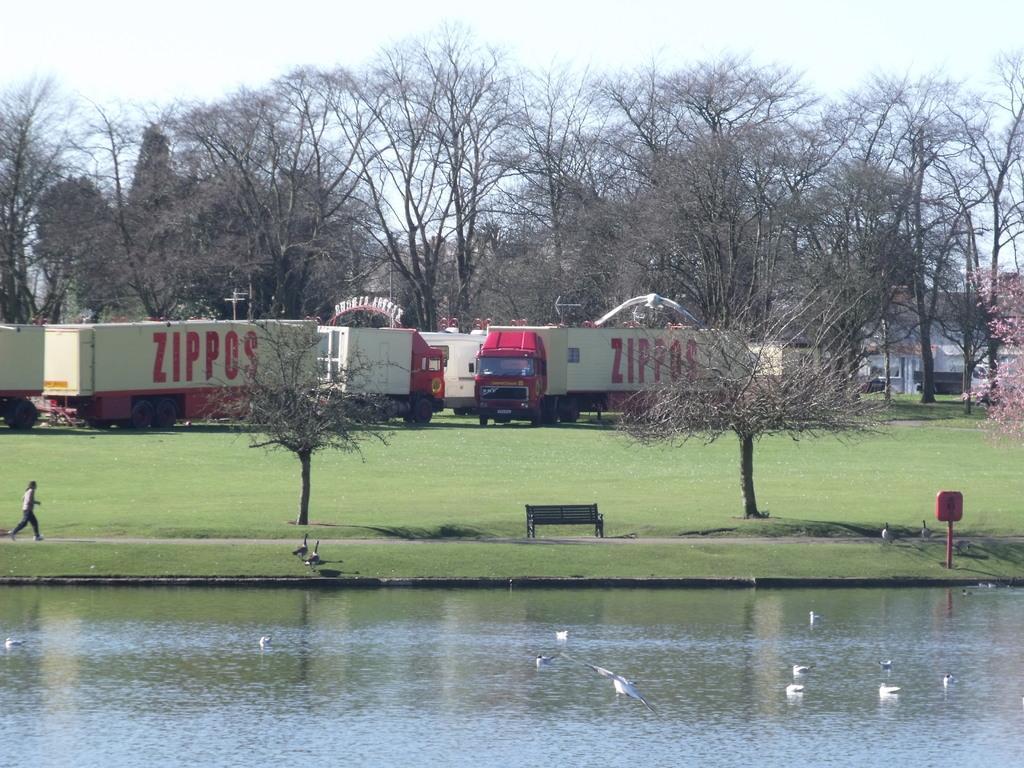Can you describe this image briefly? In the image there is a pond in the front with ducks in it and behind there are trucks on the grassland with trees behind it all over the image and above its sky. 